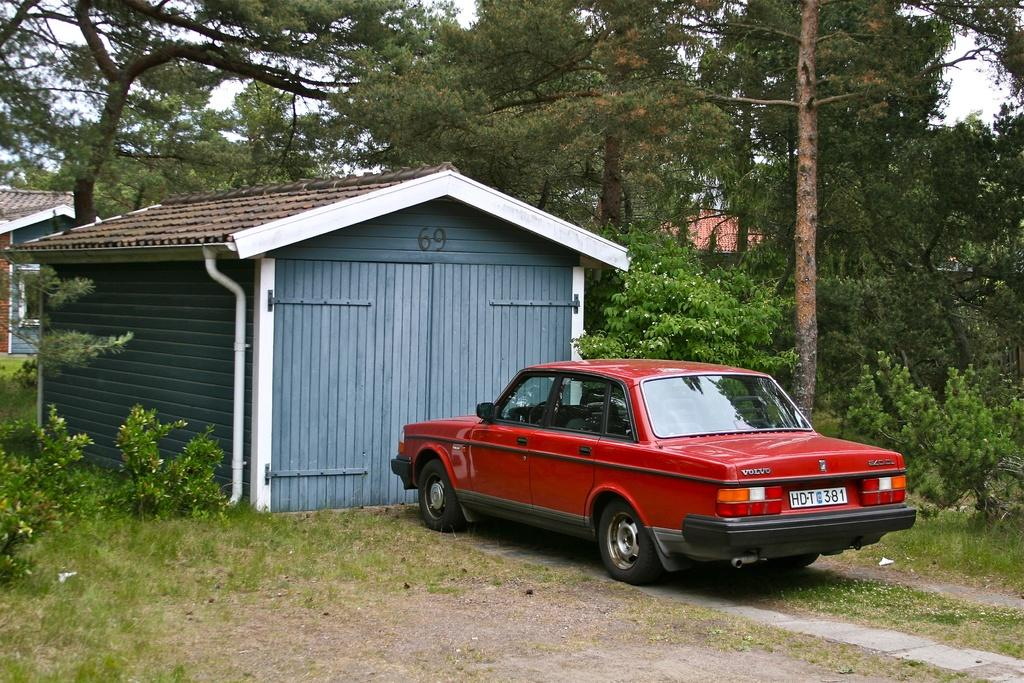What type of structures can be seen in the image? There are houses in the image. What type of vehicle is present in the image? There is a red colored car in the image. What is visible on the ground in the image? The ground is visible in the image. What type of vegetation is present in the image? There is grass, plants, and trees in the image. What part of the natural environment is visible in the image? The sky is visible in the image. How many feet can be seen walking on the grass in the image? There are no feet or people walking in the image; it only shows houses, a red car, the ground, grass, plants, trees, and the sky. What type of flesh is visible on the trees in the image? There is no flesh visible on the trees in the image; they are covered with bark and leaves. 